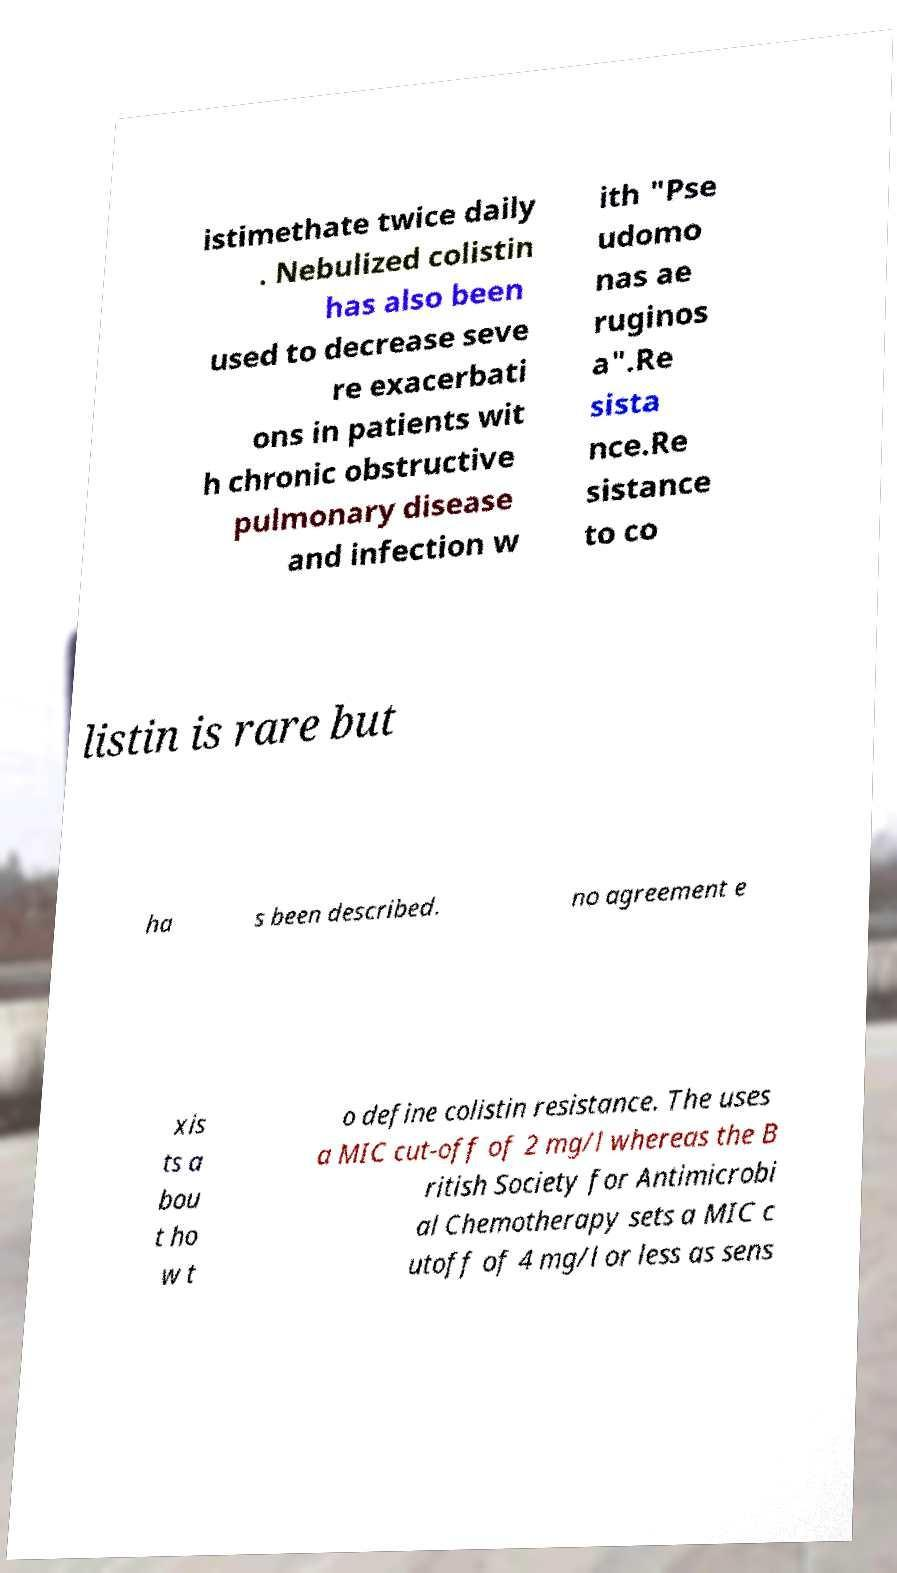There's text embedded in this image that I need extracted. Can you transcribe it verbatim? istimethate twice daily . Nebulized colistin has also been used to decrease seve re exacerbati ons in patients wit h chronic obstructive pulmonary disease and infection w ith "Pse udomo nas ae ruginos a".Re sista nce.Re sistance to co listin is rare but ha s been described. no agreement e xis ts a bou t ho w t o define colistin resistance. The uses a MIC cut-off of 2 mg/l whereas the B ritish Society for Antimicrobi al Chemotherapy sets a MIC c utoff of 4 mg/l or less as sens 